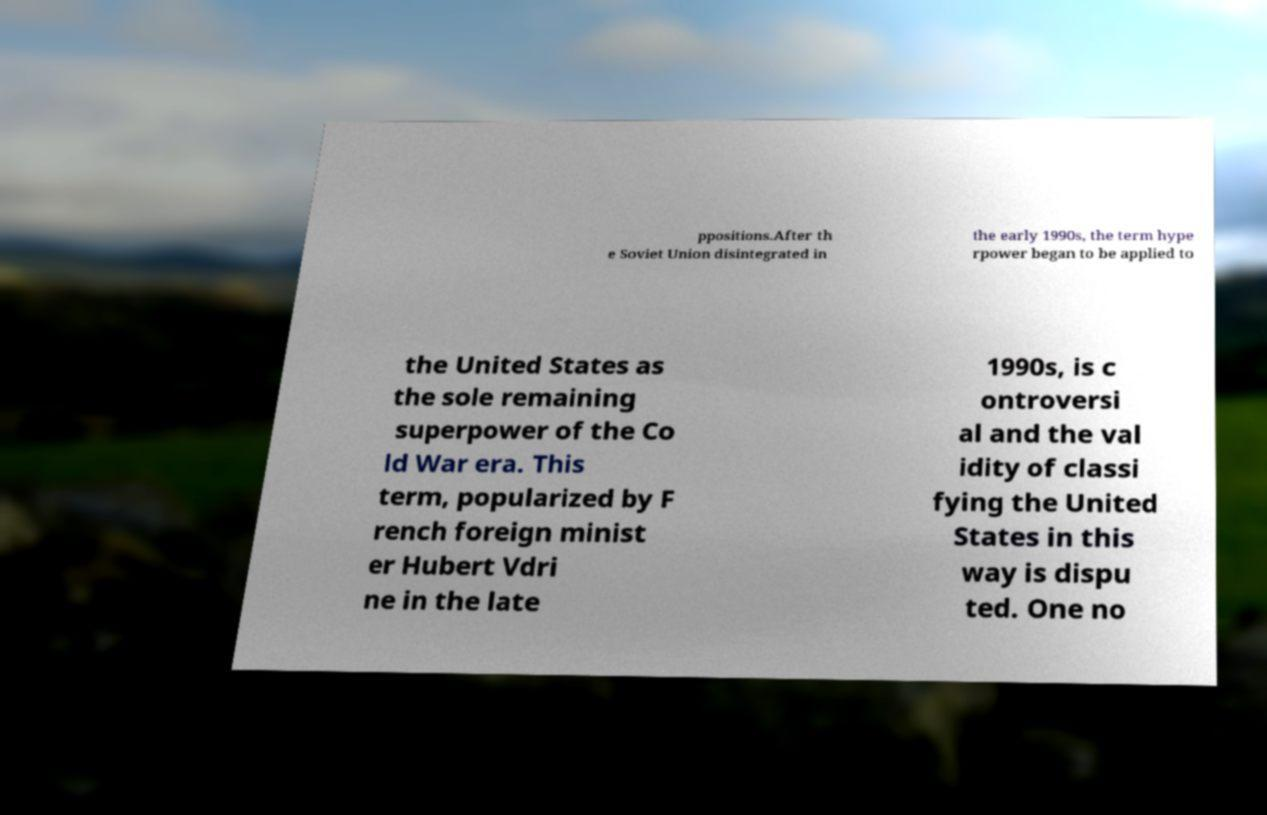For documentation purposes, I need the text within this image transcribed. Could you provide that? ppositions.After th e Soviet Union disintegrated in the early 1990s, the term hype rpower began to be applied to the United States as the sole remaining superpower of the Co ld War era. This term, popularized by F rench foreign minist er Hubert Vdri ne in the late 1990s, is c ontroversi al and the val idity of classi fying the United States in this way is dispu ted. One no 